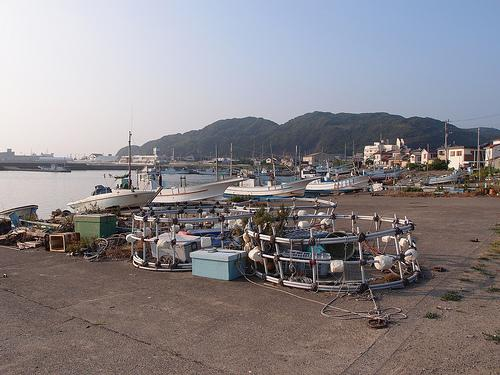Write a sentence that highlights the natural scenery in the image. The serene image captures a tree-covered hillside adjoining a calm body of water, graced by a lovely blue sky with fluffy white clouds. What are the different activities that people are involved in in the image? People are enjoying the outdoors near large crab rings, standing in front of a giraffe, and being near boats and ships at the marina. Write a concise description emphasizing the atmosphere captured in the image. A peaceful marina scene with boats on the shore, people enjoying the outdoors, and a backdrop of a tree-covered hillside under a sunny blue sky with scattered clouds. Enumerate three predominant colors found in the image along with their associated objects. Blue - sky and a blue box on the ground, Green - tree-covered hillside and a green box on the ground, White - clouds in the sky and people standing near a giraffe. Provide a brief summary of the image focusing on the significant elements. The image features a calm marina with a row of ships, several boats out of water, a tree-covered hillside, a blue sky with white clouds, and people enjoying the outdoors near large crab rings. Describe the objects found on the ground in the image. Crab rings, boxes in various colors with one having a rope attached, and ropes sprawled across the ground are some of the objects on the ground. Mention the primary feature highlighted in the upper and lower part of the image. The upper part of the image emphasizes the blue sky with white clouds, while the lower part showcases the calm marina with boats and people. 